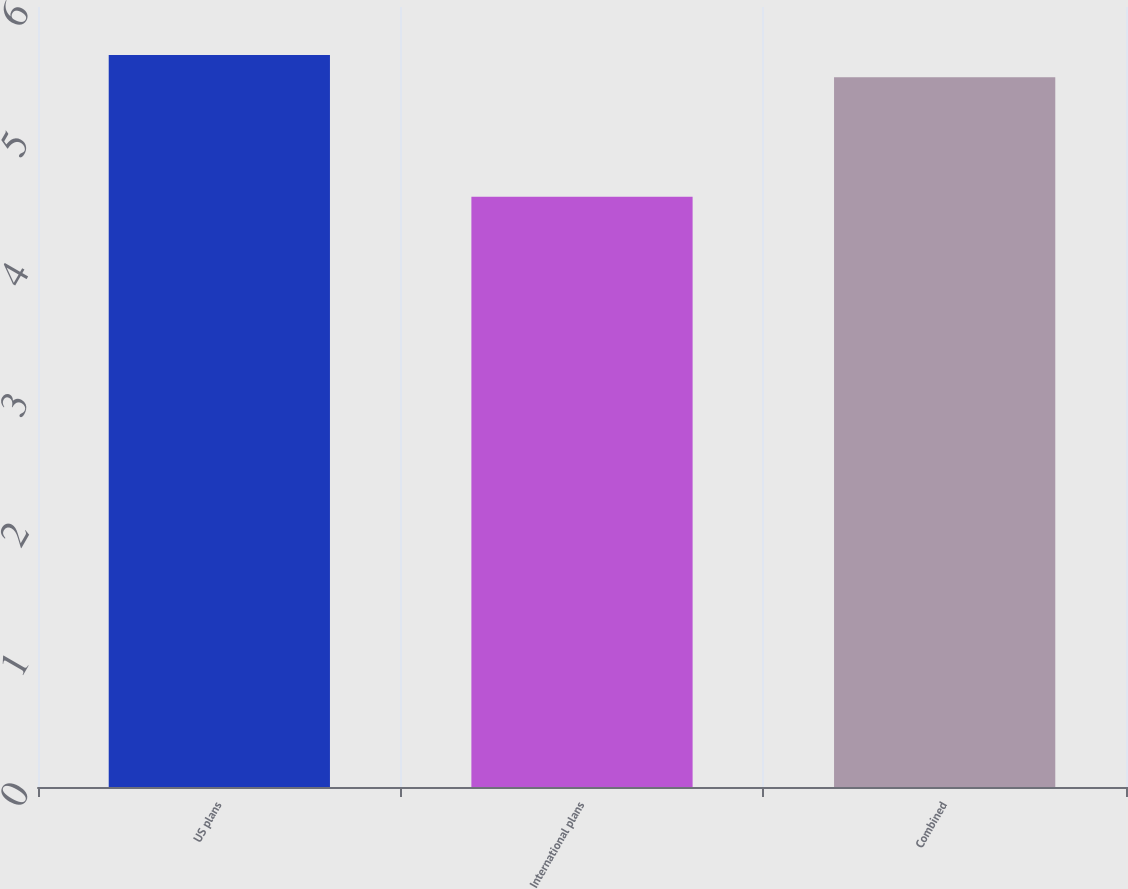Convert chart to OTSL. <chart><loc_0><loc_0><loc_500><loc_500><bar_chart><fcel>US plans<fcel>International plans<fcel>Combined<nl><fcel>5.63<fcel>4.54<fcel>5.46<nl></chart> 